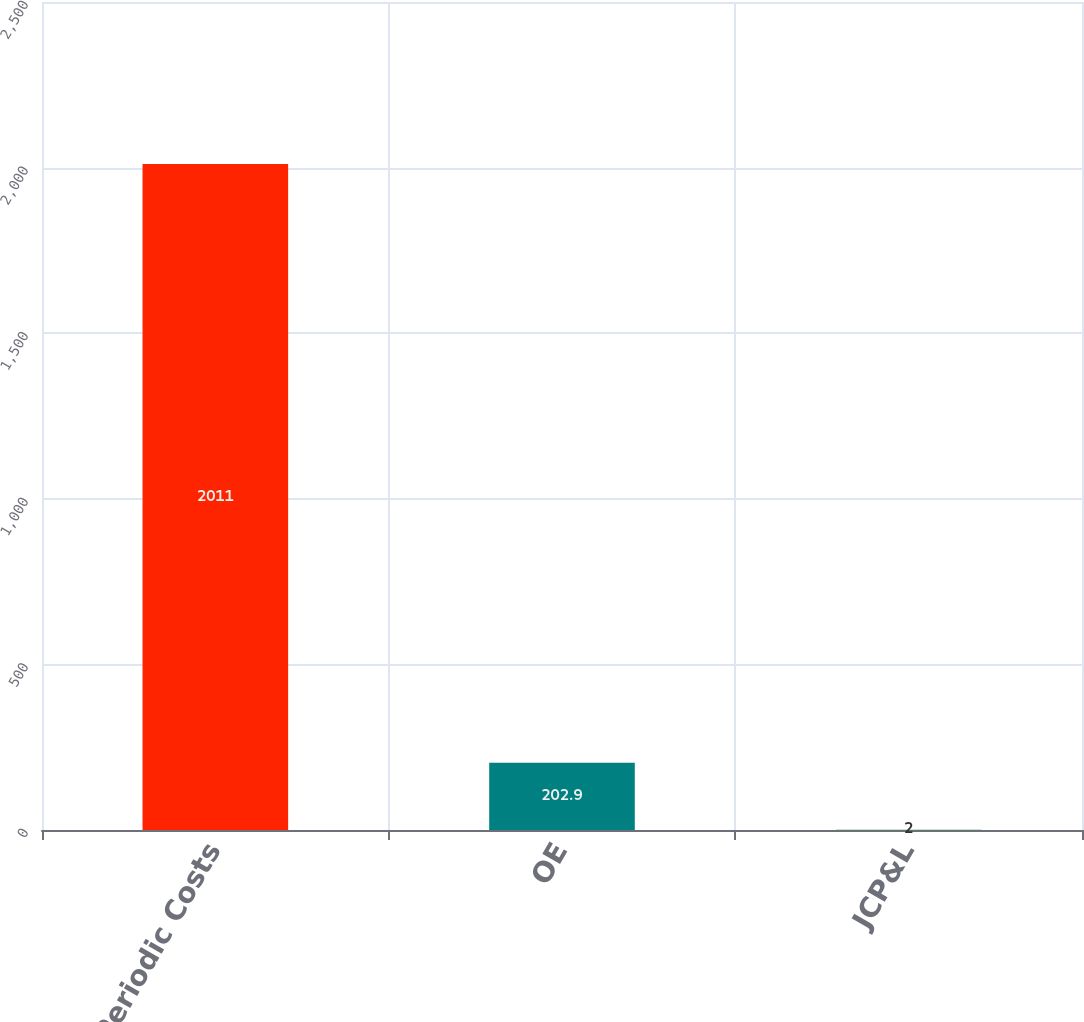<chart> <loc_0><loc_0><loc_500><loc_500><bar_chart><fcel>Net Periodic Costs<fcel>OE<fcel>JCP&L<nl><fcel>2011<fcel>202.9<fcel>2<nl></chart> 